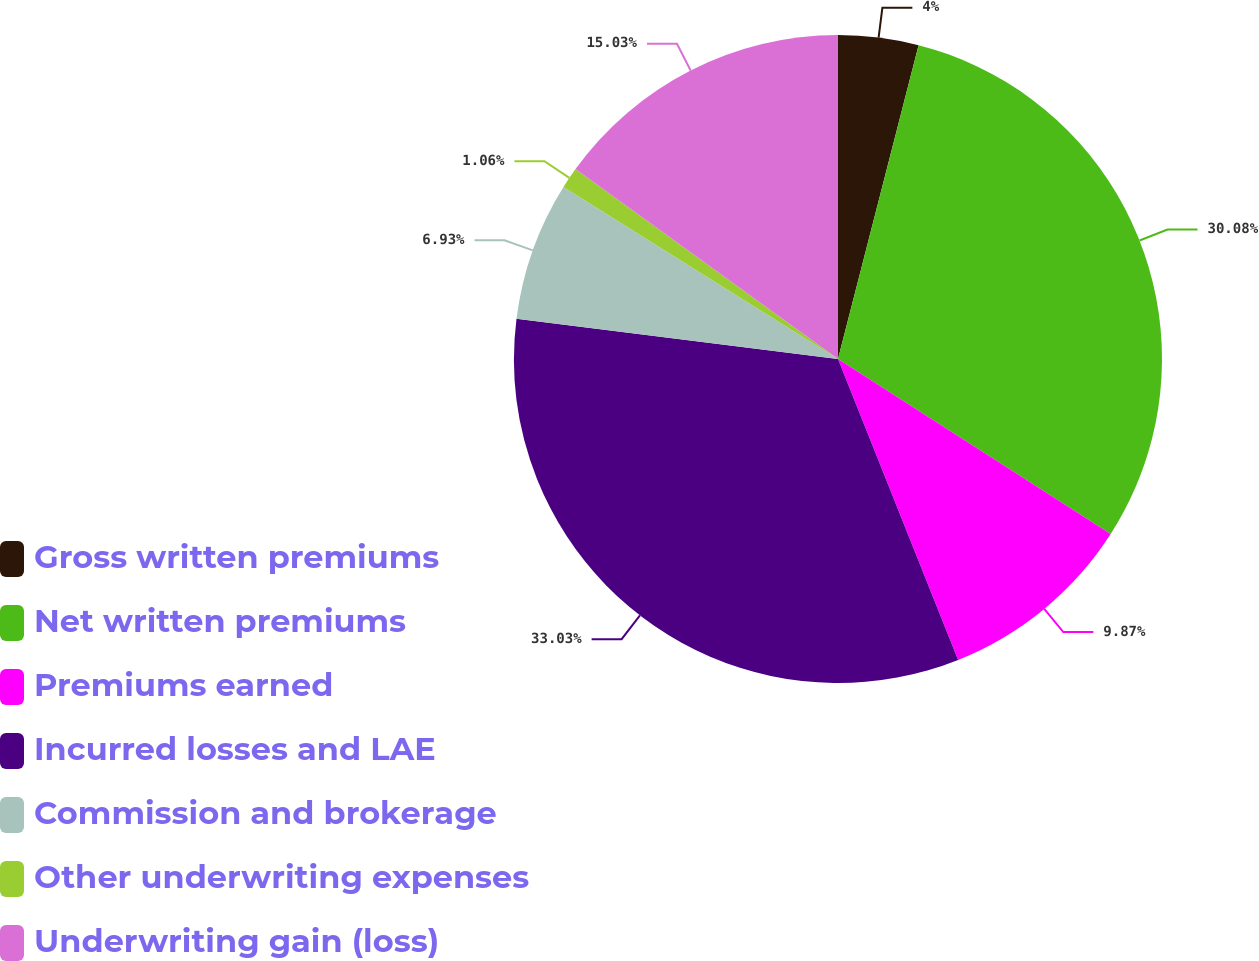Convert chart to OTSL. <chart><loc_0><loc_0><loc_500><loc_500><pie_chart><fcel>Gross written premiums<fcel>Net written premiums<fcel>Premiums earned<fcel>Incurred losses and LAE<fcel>Commission and brokerage<fcel>Other underwriting expenses<fcel>Underwriting gain (loss)<nl><fcel>4.0%<fcel>30.08%<fcel>9.87%<fcel>33.02%<fcel>6.93%<fcel>1.06%<fcel>15.03%<nl></chart> 